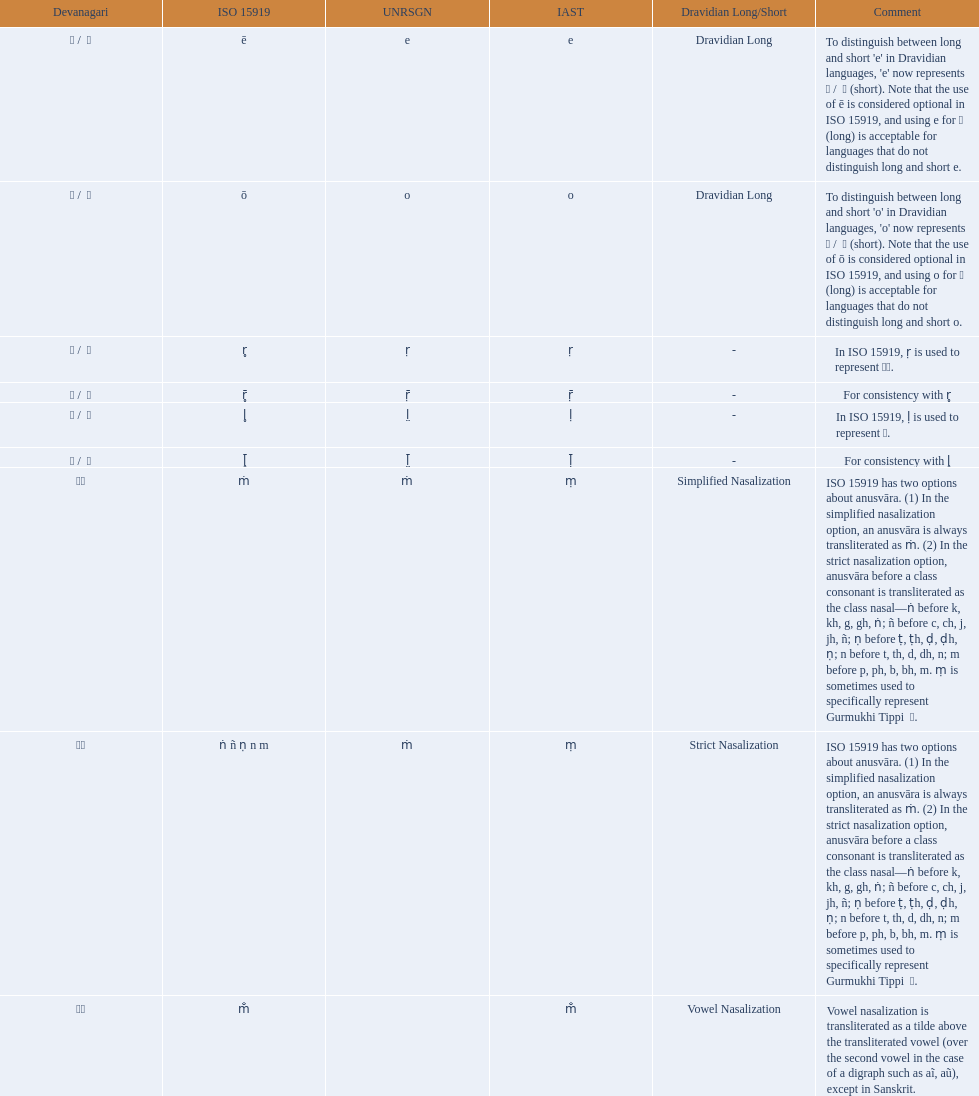Which devanagari symbol corresponds to this iast character: o? ओ / ो. 